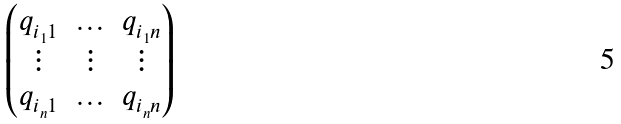Convert formula to latex. <formula><loc_0><loc_0><loc_500><loc_500>\begin{pmatrix} q _ { i _ { 1 } 1 } & \hdots & q _ { i _ { 1 } n } \\ \vdots & \vdots & \vdots \\ q _ { i _ { n } 1 } & \hdots & q _ { i _ { n } n } \end{pmatrix}</formula> 